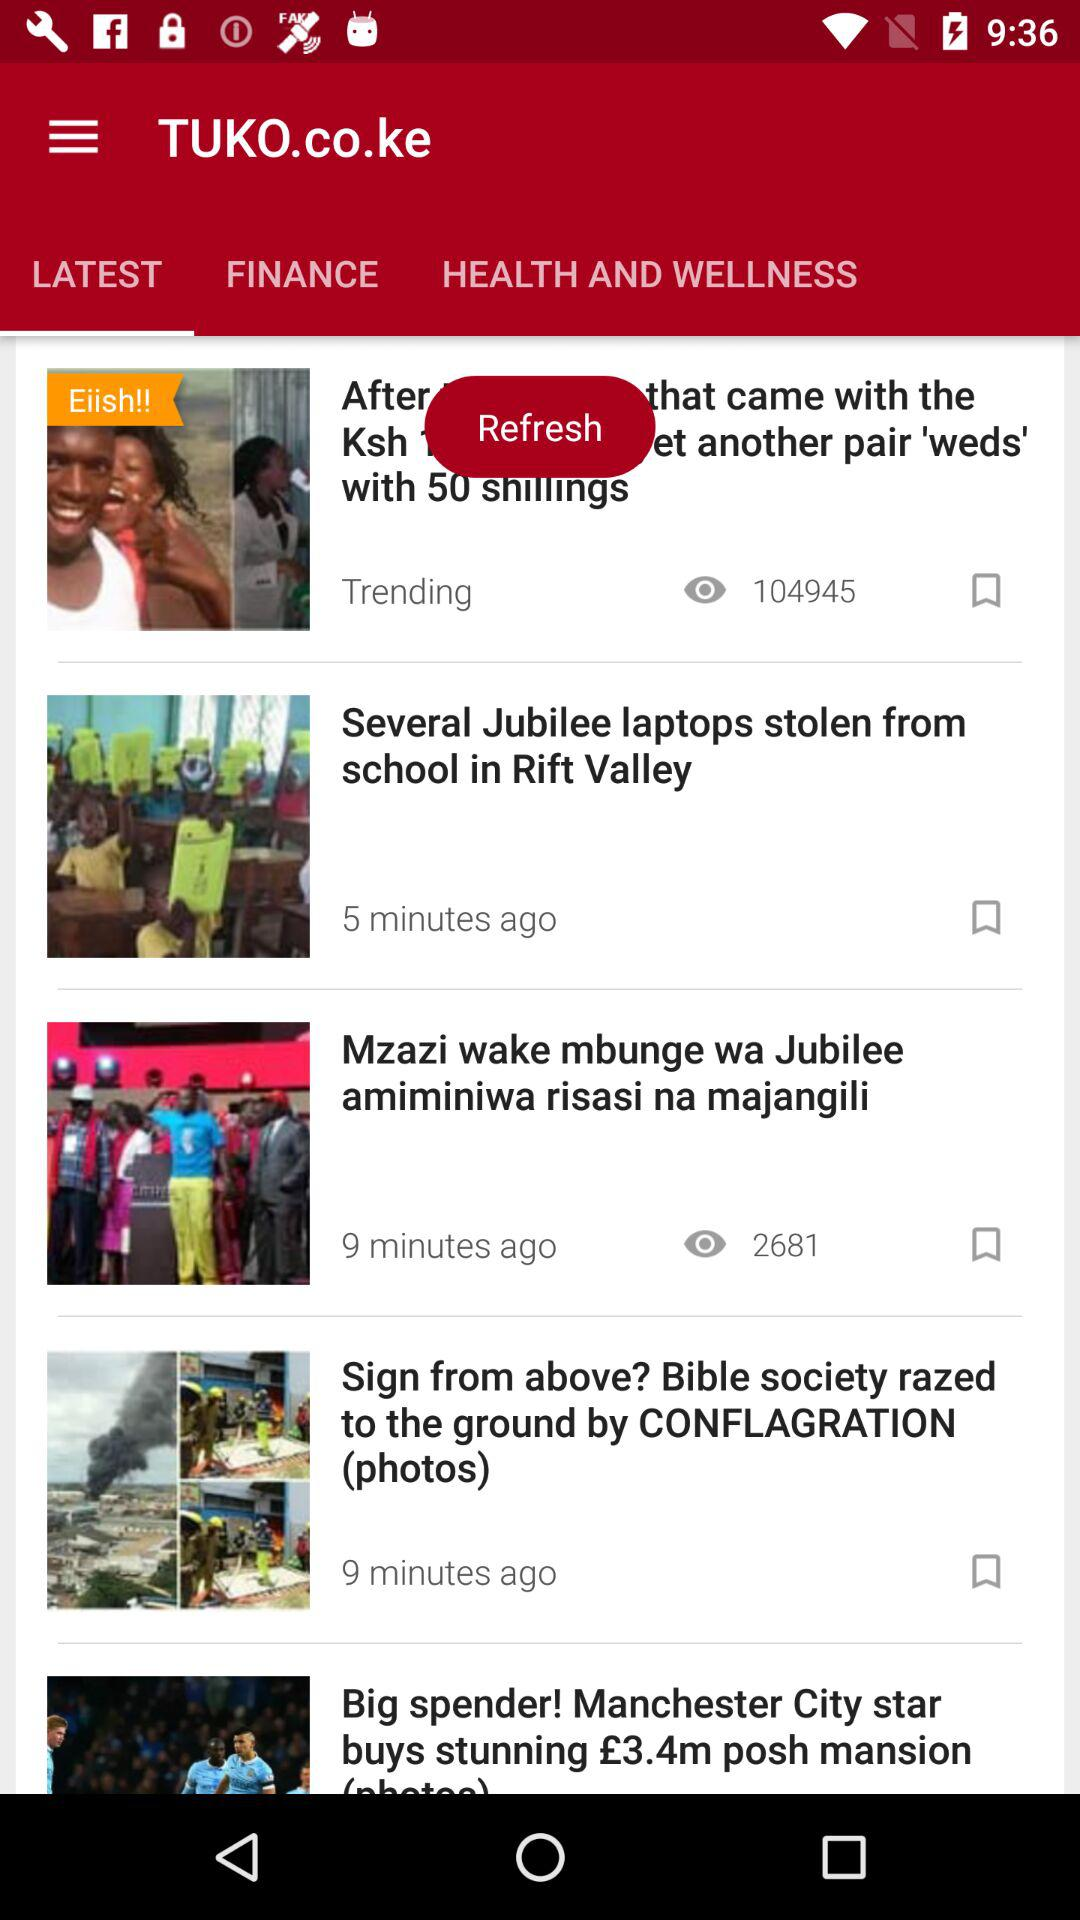Which news was posted 5 minutes ago? The news that was posted 5 minutes ago is "Several Jubilee laptops stolen from school in Rift Valley". 